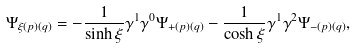Convert formula to latex. <formula><loc_0><loc_0><loc_500><loc_500>\Psi _ { \xi ( p ) ( q ) } = - \frac { 1 } { \sinh \xi } \gamma ^ { 1 } \gamma ^ { 0 } \Psi _ { + ( p ) ( q ) } - \frac { 1 } { \cosh \xi } \gamma ^ { 1 } \gamma ^ { 2 } \Psi _ { - ( p ) ( q ) } ,</formula> 